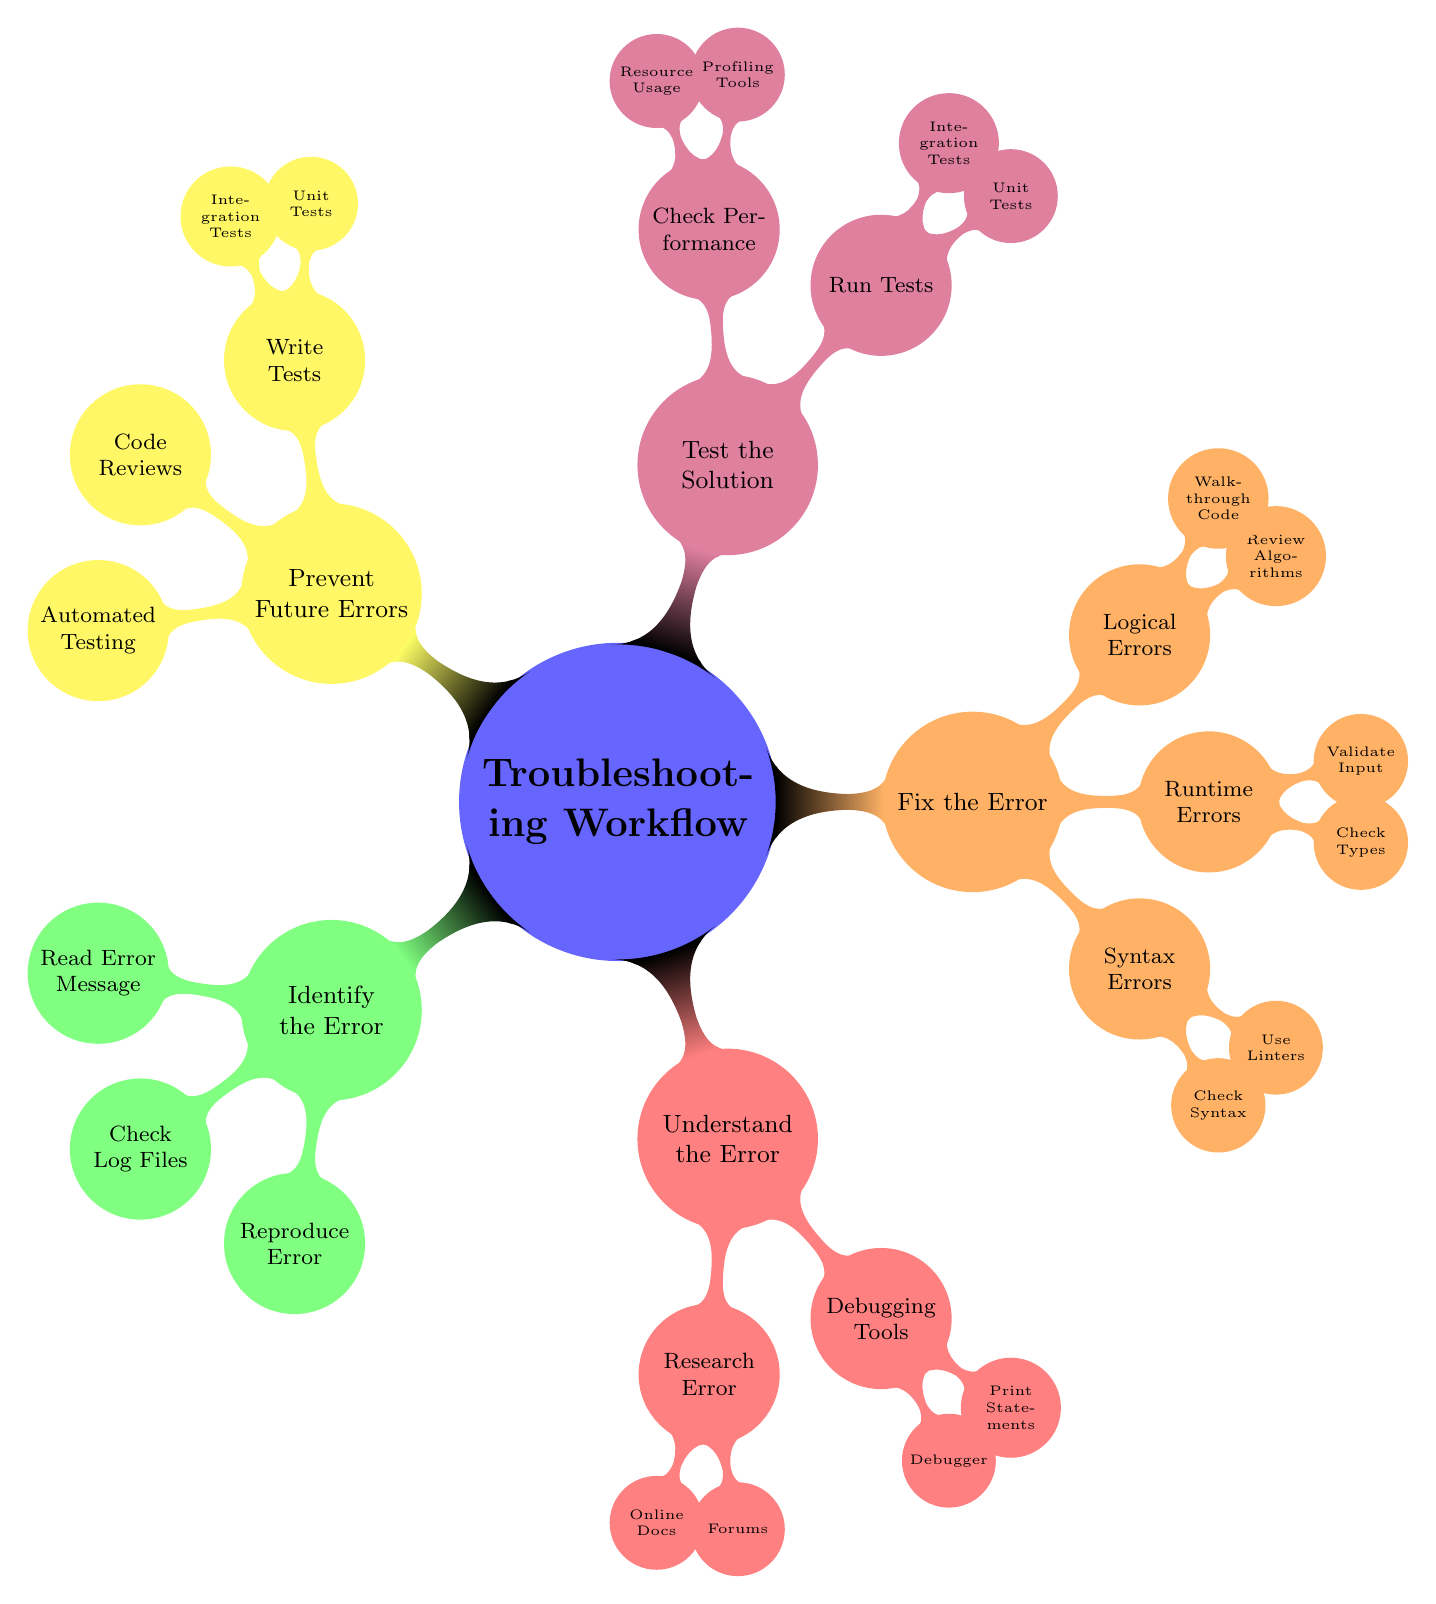What are the five main categories in the troubleshooting workflow? The diagram has five main categories branching out from the central idea of "Troubleshooting Workflow." Those categories are "Identify the Error," "Understand the Error," "Fix the Error," "Test the Solution," and "Prevent Future Errors."
Answer: Identify the Error, Understand the Error, Fix the Error, Test the Solution, Prevent Future Errors How many nodes are under "Fix the Error"? Under the category "Fix the Error," there are three main nodes: "Syntax Errors," "Runtime Errors," and "Logical Errors." Each of these serves as a sub-category for handling errors, making a total of three nodes.
Answer: Three What will you check first to identify an error? According to the diagram, the first step in identifying an error involves reading the error message. This initial action helps understand what went wrong.
Answer: Read the Error Message Which part of the workflow includes the use of profiling tools? The use of profiling tools is found in the "Check Performance" node, which is a part of the "Test the Solution" category. This node is focused on ensuring the solution's efficiency and effectiveness.
Answer: Check Performance What is the purpose of code reviews in the workflow? Code reviews fall under the "Prevent Future Errors" category, and their purpose is to identify potential issues in the code before they cause errors, thus fostering better coding practices and preventing future troubles.
Answer: Identify potential issues What type of tests are run under "Test the Solution"? Under the "Run Tests" node in the "Test the Solution" category, both "Unit Tests" and "Integration Tests" are specified. These types of tests are crucial for verifying that the solution works as intended.
Answer: Unit Tests, Integration Tests How does researching the error help in understanding it? Researching the error, as indicated in the "Understand the Error" category, involves checking online documentation and forums which allow developers to gather information that can clarify the root cause of the error, thus fostering a deeper understanding.
Answer: Clarify the root cause What action directly precedes writing tests in the troubleshooting process? In the troubleshooting process, the action that directly precedes writing tests is performing a debug of the code, as indicated in the "Fix the Error" category, to ensure that the errors have been appropriately addressed before creating tests.
Answer: Debug the code 